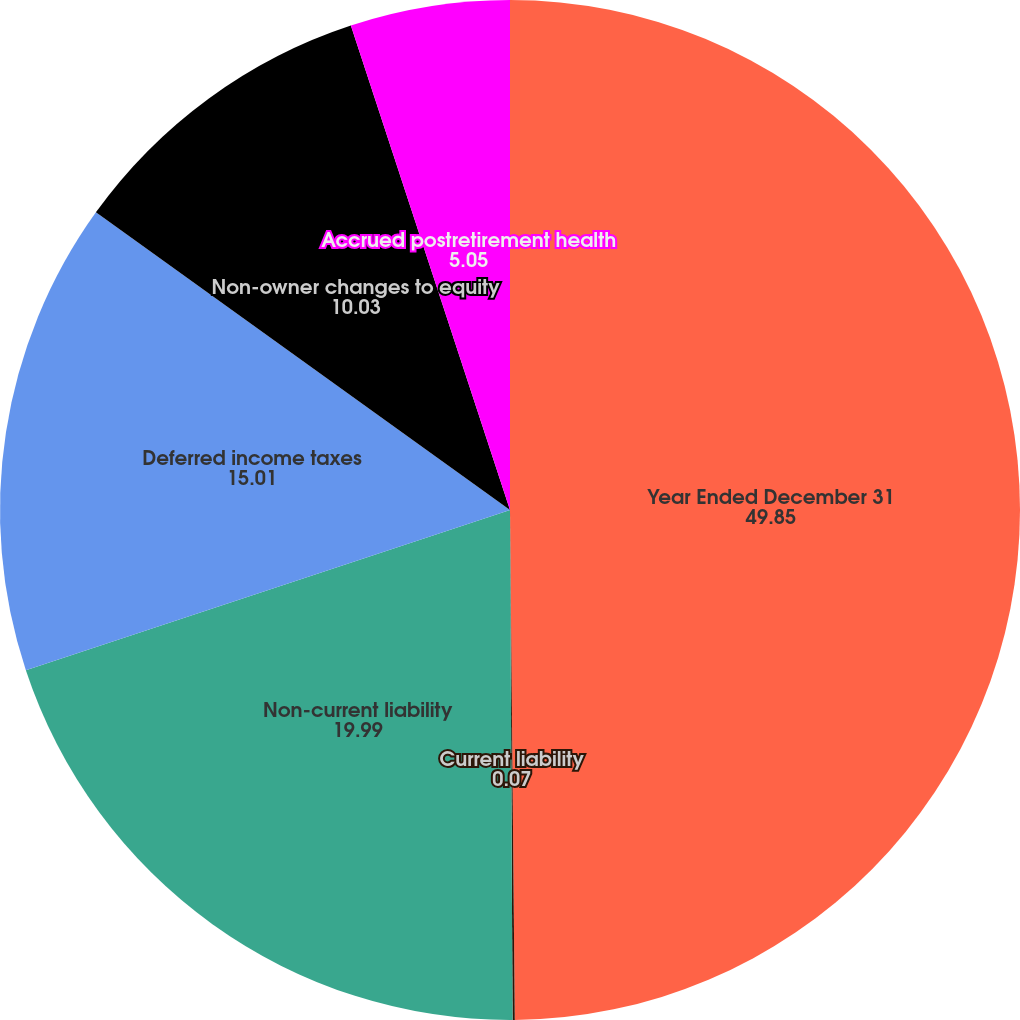Convert chart. <chart><loc_0><loc_0><loc_500><loc_500><pie_chart><fcel>Year Ended December 31<fcel>Current liability<fcel>Non-current liability<fcel>Deferred income taxes<fcel>Non-owner changes to equity<fcel>Accrued postretirement health<nl><fcel>49.85%<fcel>0.07%<fcel>19.99%<fcel>15.01%<fcel>10.03%<fcel>5.05%<nl></chart> 